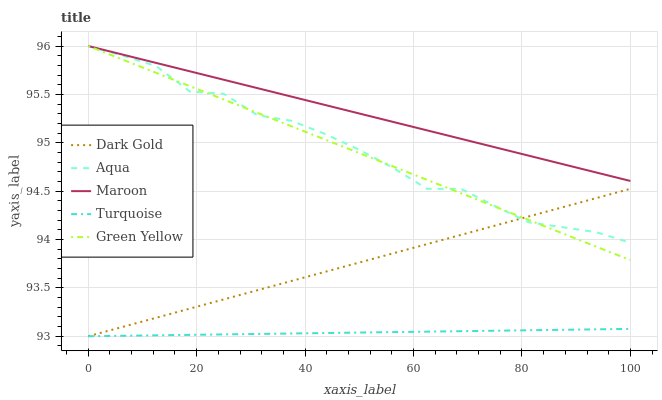Does Turquoise have the minimum area under the curve?
Answer yes or no. Yes. Does Maroon have the maximum area under the curve?
Answer yes or no. Yes. Does Green Yellow have the minimum area under the curve?
Answer yes or no. No. Does Green Yellow have the maximum area under the curve?
Answer yes or no. No. Is Green Yellow the smoothest?
Answer yes or no. Yes. Is Aqua the roughest?
Answer yes or no. Yes. Is Aqua the smoothest?
Answer yes or no. No. Is Green Yellow the roughest?
Answer yes or no. No. Does Turquoise have the lowest value?
Answer yes or no. Yes. Does Green Yellow have the lowest value?
Answer yes or no. No. Does Maroon have the highest value?
Answer yes or no. Yes. Does Dark Gold have the highest value?
Answer yes or no. No. Is Turquoise less than Aqua?
Answer yes or no. Yes. Is Green Yellow greater than Turquoise?
Answer yes or no. Yes. Does Maroon intersect Aqua?
Answer yes or no. Yes. Is Maroon less than Aqua?
Answer yes or no. No. Is Maroon greater than Aqua?
Answer yes or no. No. Does Turquoise intersect Aqua?
Answer yes or no. No. 